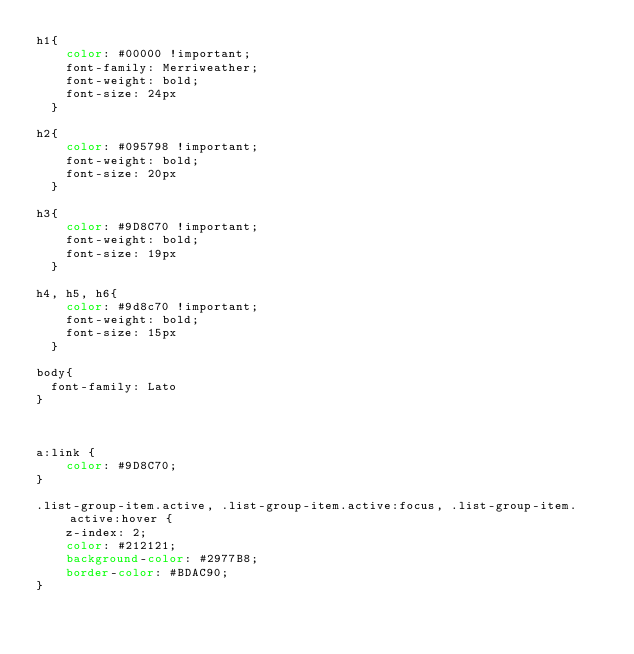<code> <loc_0><loc_0><loc_500><loc_500><_CSS_>h1{
    color: #00000 !important;
    font-family: Merriweather;
    font-weight: bold;
    font-size: 24px
  }

h2{
    color: #095798 !important;
    font-weight: bold;
    font-size: 20px
  }

h3{
    color: #9D8C70 !important;
    font-weight: bold;
    font-size: 19px
  }

h4, h5, h6{
    color: #9d8c70 !important;
    font-weight: bold;
    font-size: 15px
  }

body{
  font-family: Lato
}



a:link {
    color: #9D8C70;
}

.list-group-item.active, .list-group-item.active:focus, .list-group-item.active:hover {
    z-index: 2;
    color: #212121;
    background-color: #2977B8;
    border-color: #BDAC90;
}
</code> 